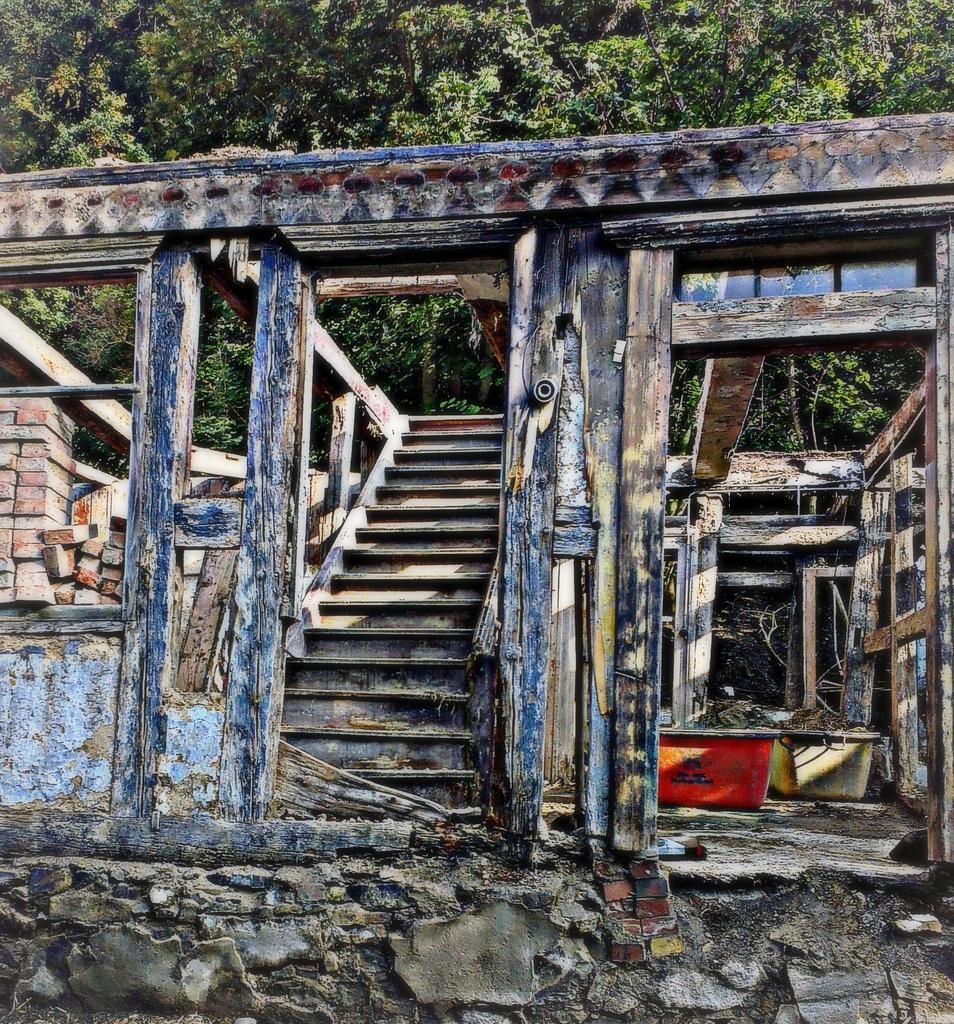Describe this image in one or two sentences. In this picture, we see a wooden house or a building. This building might be in construction. In the middle of the picture, we see a staircase. On the right side, we see red and yellow color things which look like boxes or tubs. On the left side, we see wooden boxes. There are trees in the background. 